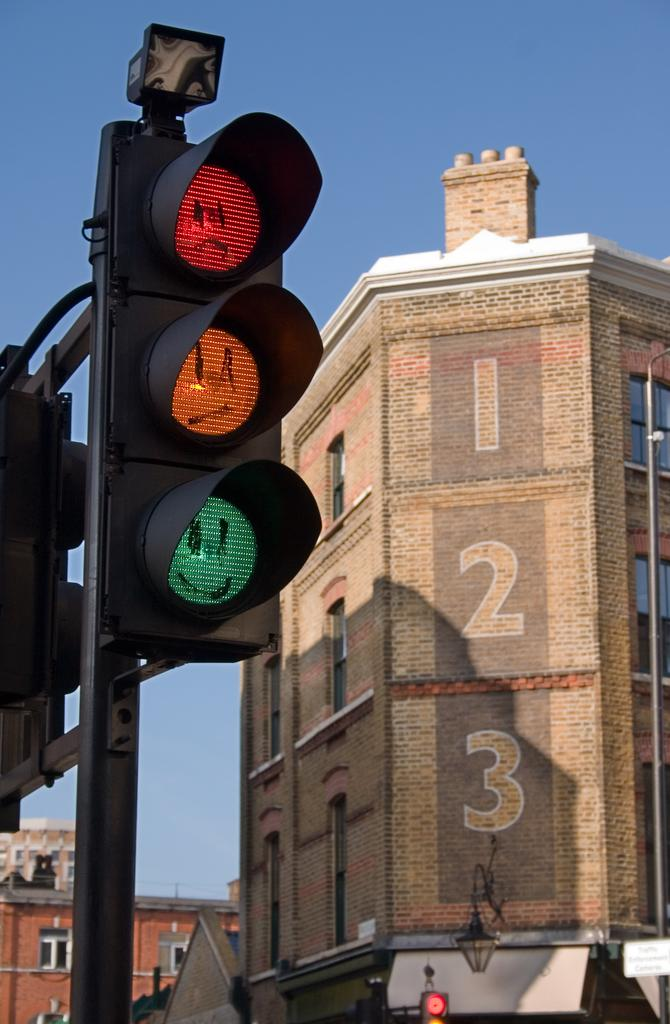<image>
Write a terse but informative summary of the picture. A brick building has the numbers 1, 2, 3 down the side. 